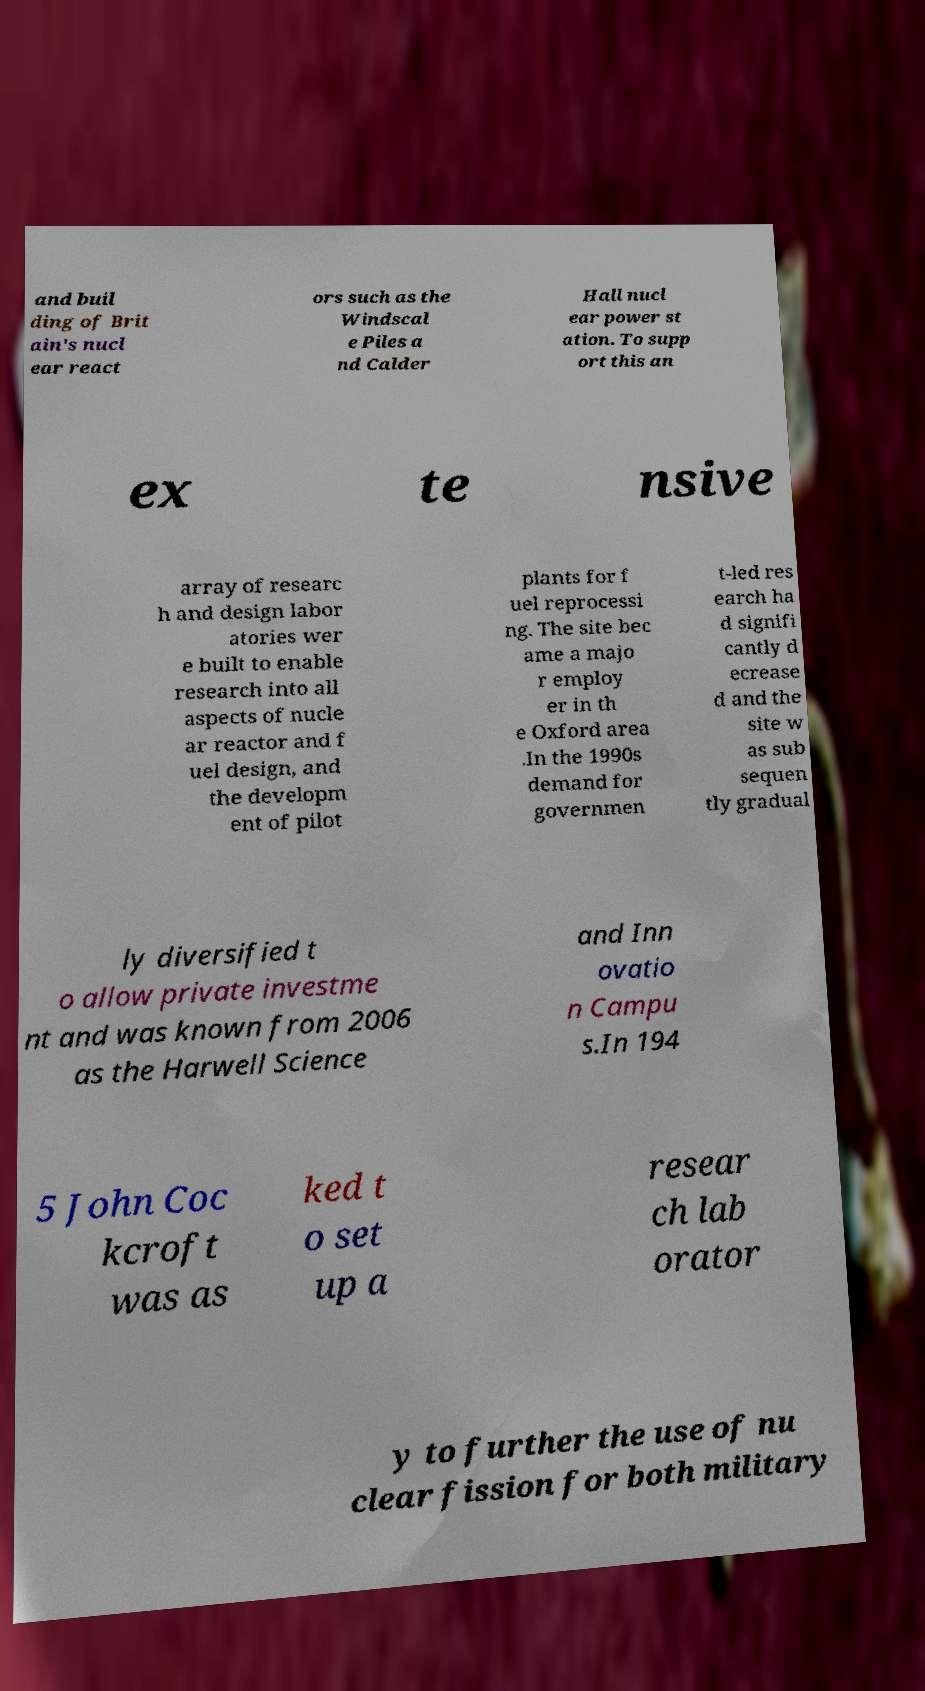I need the written content from this picture converted into text. Can you do that? and buil ding of Brit ain's nucl ear react ors such as the Windscal e Piles a nd Calder Hall nucl ear power st ation. To supp ort this an ex te nsive array of researc h and design labor atories wer e built to enable research into all aspects of nucle ar reactor and f uel design, and the developm ent of pilot plants for f uel reprocessi ng. The site bec ame a majo r employ er in th e Oxford area .In the 1990s demand for governmen t-led res earch ha d signifi cantly d ecrease d and the site w as sub sequen tly gradual ly diversified t o allow private investme nt and was known from 2006 as the Harwell Science and Inn ovatio n Campu s.In 194 5 John Coc kcroft was as ked t o set up a resear ch lab orator y to further the use of nu clear fission for both military 